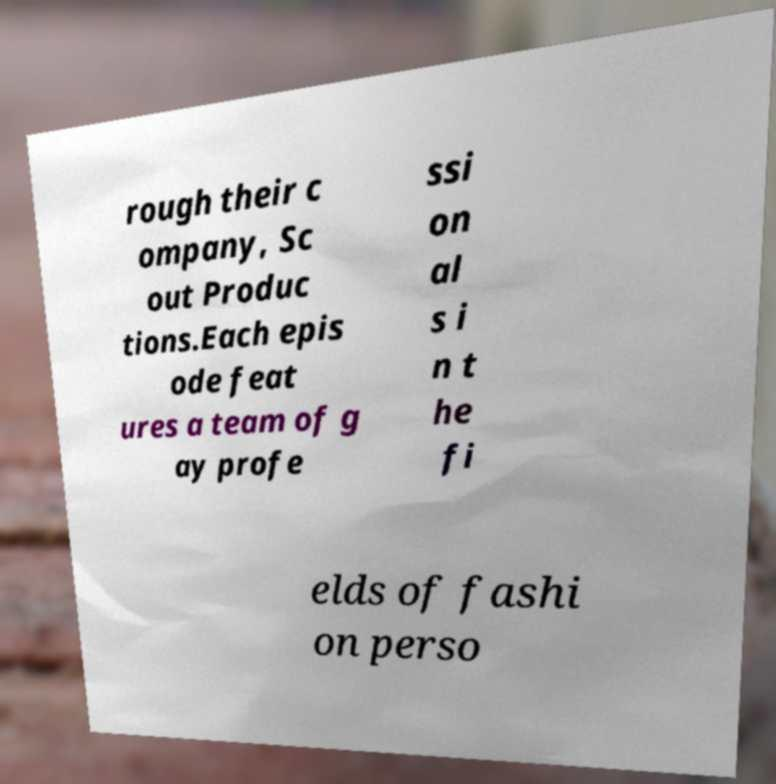Can you read and provide the text displayed in the image?This photo seems to have some interesting text. Can you extract and type it out for me? rough their c ompany, Sc out Produc tions.Each epis ode feat ures a team of g ay profe ssi on al s i n t he fi elds of fashi on perso 